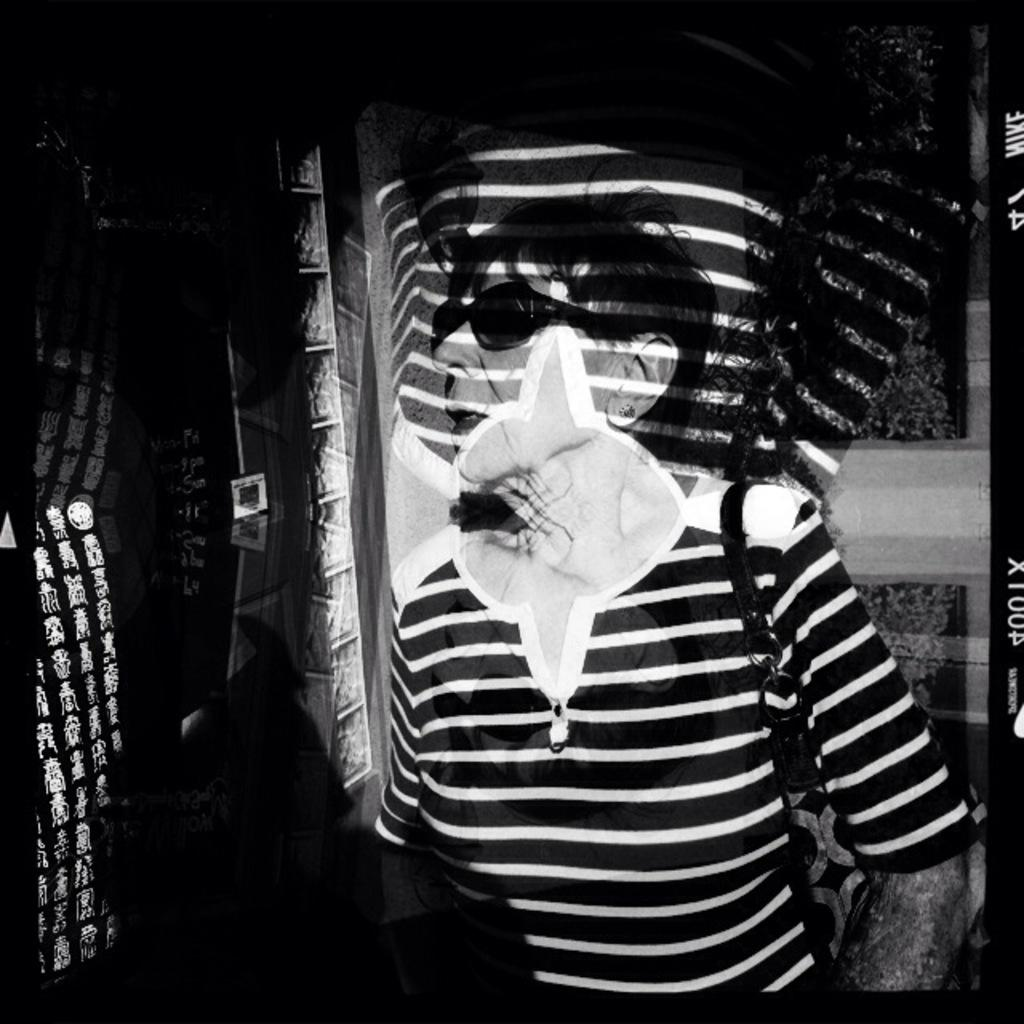What is the color scheme of the image? The image is black and white. Can you describe the main subject in the image? There is a woman in the image. What type of curve can be seen in the image? There is no curve present in the image; it is a black and white image featuring a woman. 